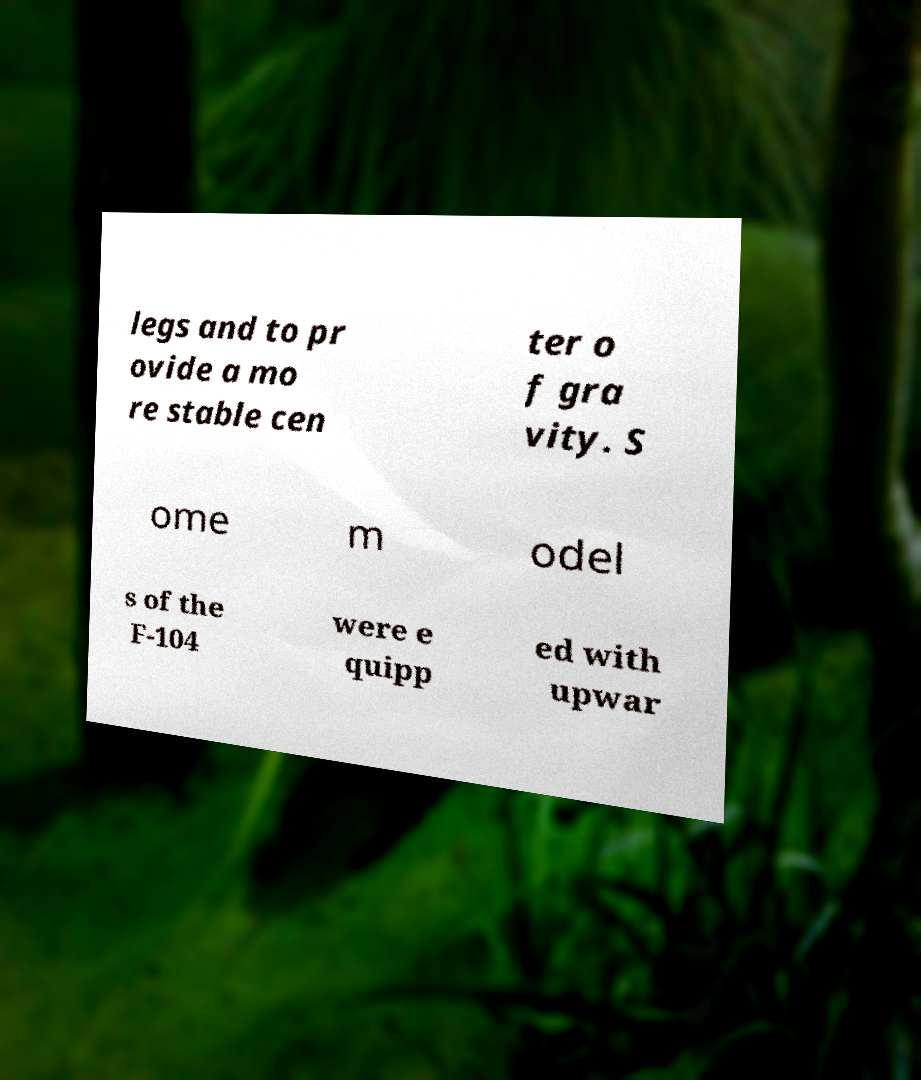What messages or text are displayed in this image? I need them in a readable, typed format. legs and to pr ovide a mo re stable cen ter o f gra vity. S ome m odel s of the F-104 were e quipp ed with upwar 